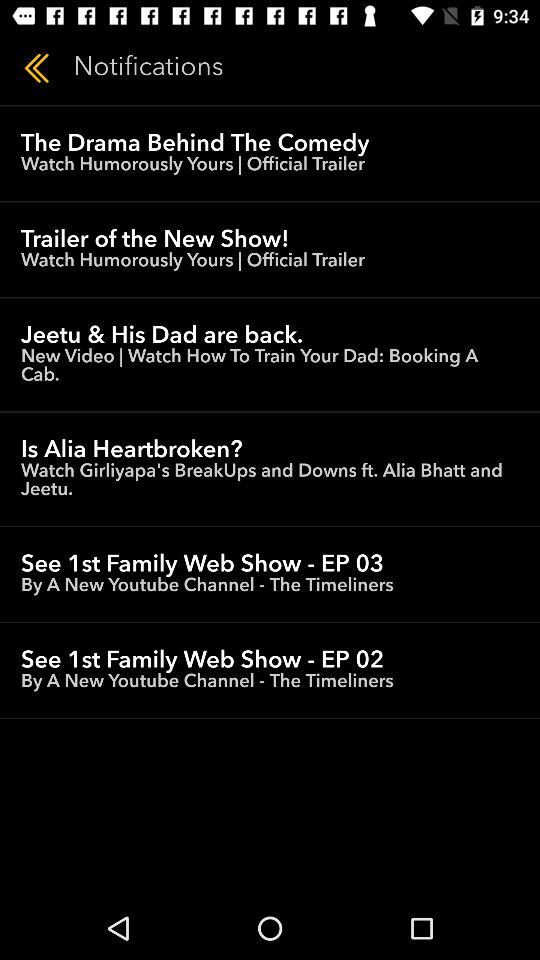What is the name of the show with episode 03? The name of the show is "1st Family". 